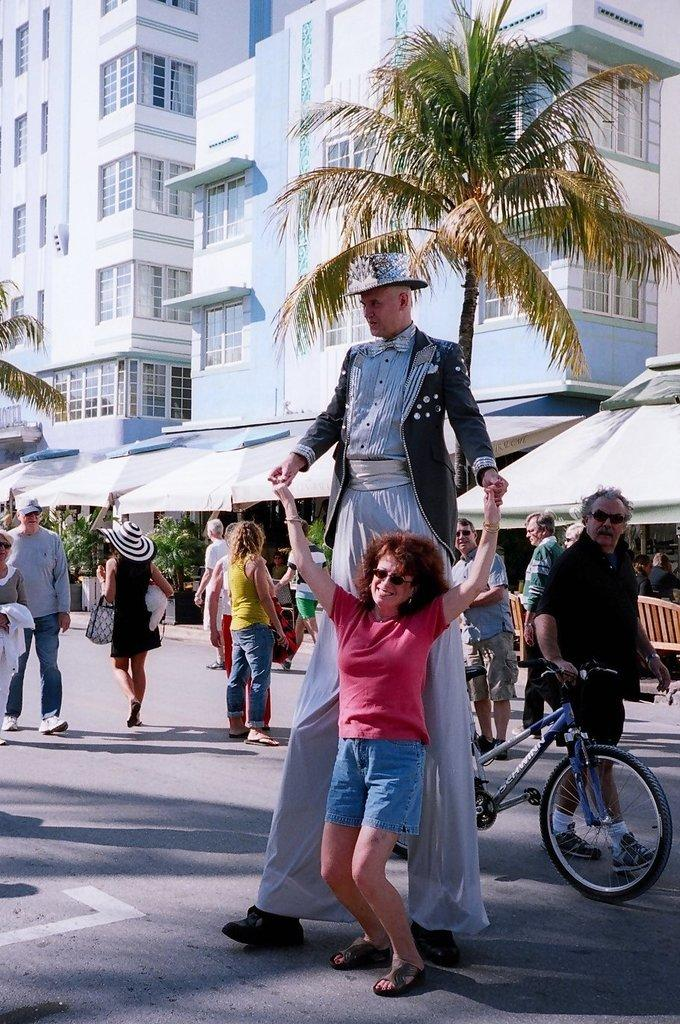What is the main focus of the image? The main focus of the image is the people in the center. What can be seen in the background of the image? There are buildings and trees in the background of the image. What else is present in the center of the image besides the people? There are stalls in the center of the image. Can you see the throne that the king is sitting on in the image? There is no throne or king present in the image. Are the people in the image kissing each other? There is no indication of kissing in the image; it only shows people and stalls in the center. 